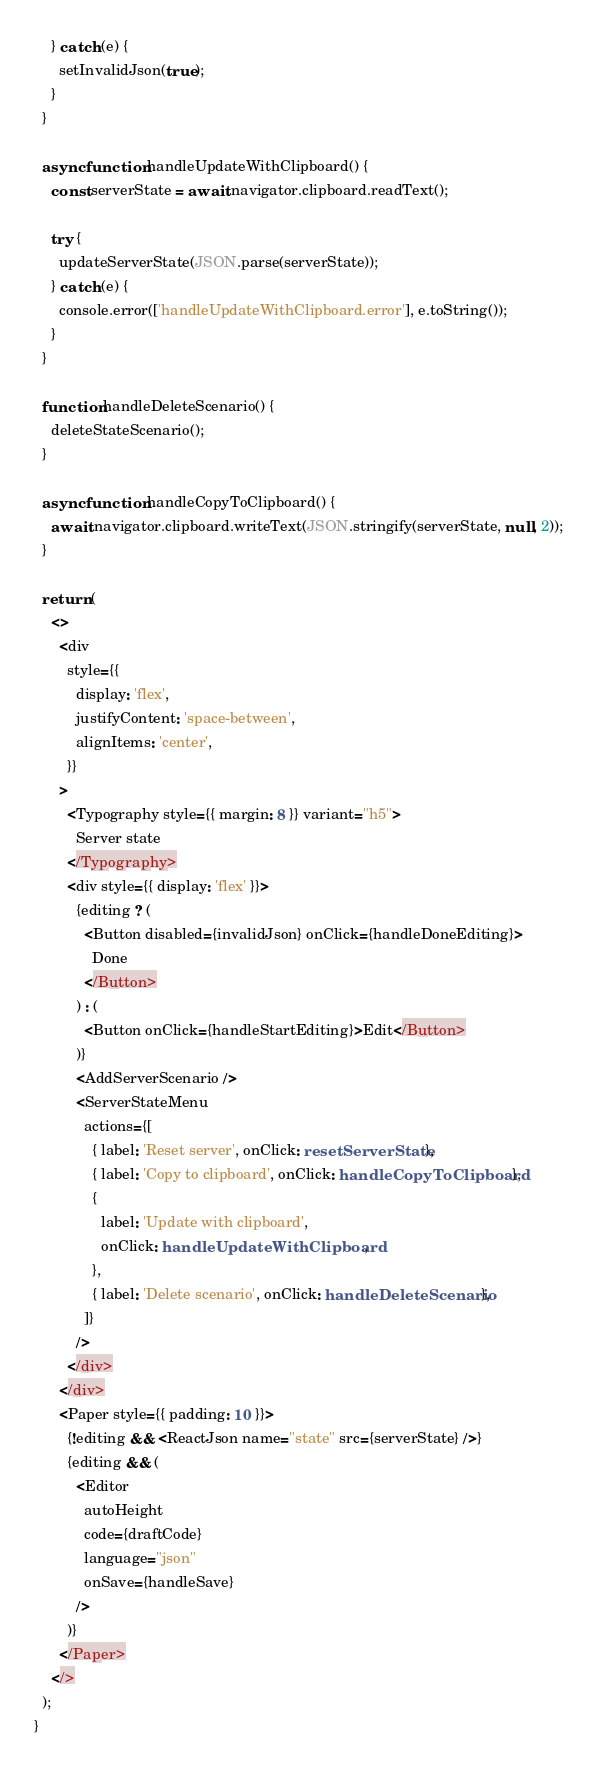<code> <loc_0><loc_0><loc_500><loc_500><_TypeScript_>    } catch (e) {
      setInvalidJson(true);
    }
  }

  async function handleUpdateWithClipboard() {
    const serverState = await navigator.clipboard.readText();

    try {
      updateServerState(JSON.parse(serverState));
    } catch (e) {
      console.error(['handleUpdateWithClipboard.error'], e.toString());
    }
  }

  function handleDeleteScenario() {
    deleteStateScenario();
  }

  async function handleCopyToClipboard() {
    await navigator.clipboard.writeText(JSON.stringify(serverState, null, 2));
  }

  return (
    <>
      <div
        style={{
          display: 'flex',
          justifyContent: 'space-between',
          alignItems: 'center',
        }}
      >
        <Typography style={{ margin: 8 }} variant="h5">
          Server state
        </Typography>
        <div style={{ display: 'flex' }}>
          {editing ? (
            <Button disabled={invalidJson} onClick={handleDoneEditing}>
              Done
            </Button>
          ) : (
            <Button onClick={handleStartEditing}>Edit</Button>
          )}
          <AddServerScenario />
          <ServerStateMenu
            actions={[
              { label: 'Reset server', onClick: resetServerState },
              { label: 'Copy to clipboard', onClick: handleCopyToClipboard },
              {
                label: 'Update with clipboard',
                onClick: handleUpdateWithClipboard,
              },
              { label: 'Delete scenario', onClick: handleDeleteScenario },
            ]}
          />
        </div>
      </div>
      <Paper style={{ padding: 10 }}>
        {!editing && <ReactJson name="state" src={serverState} />}
        {editing && (
          <Editor
            autoHeight
            code={draftCode}
            language="json"
            onSave={handleSave}
          />
        )}
      </Paper>
    </>
  );
}
</code> 